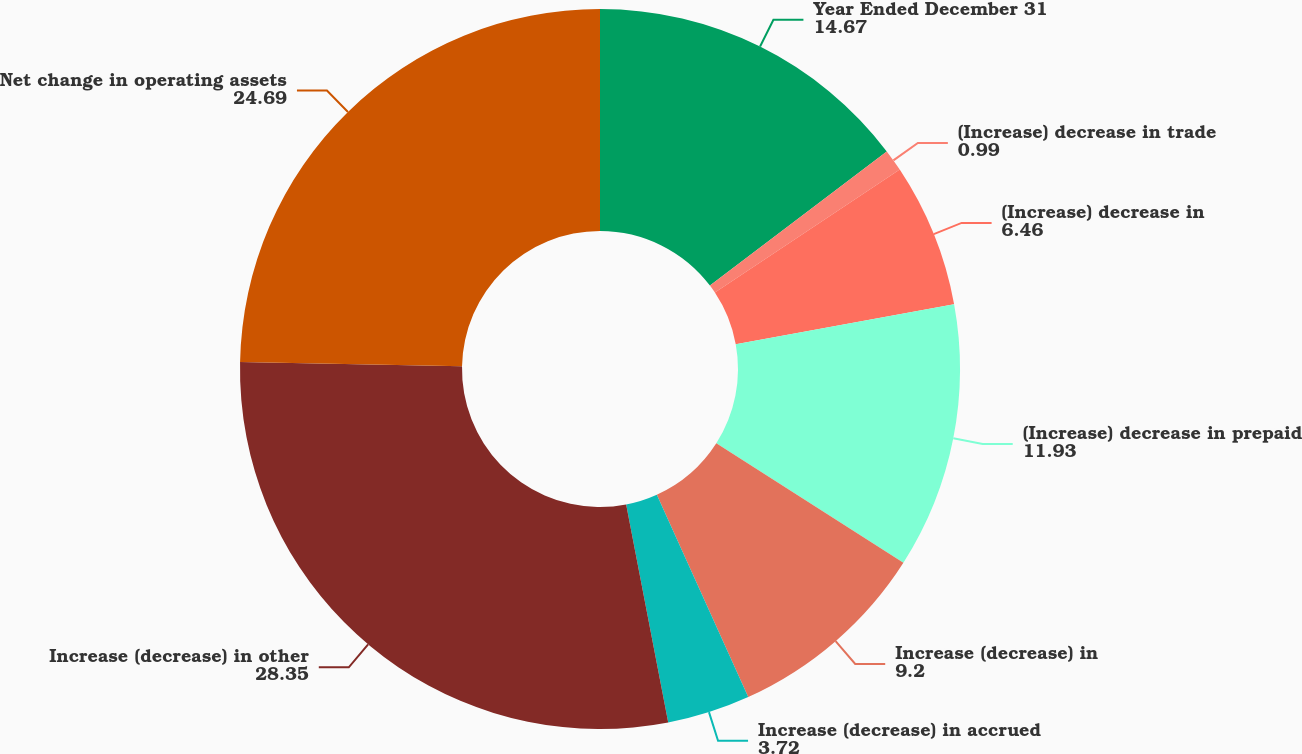Convert chart. <chart><loc_0><loc_0><loc_500><loc_500><pie_chart><fcel>Year Ended December 31<fcel>(Increase) decrease in trade<fcel>(Increase) decrease in<fcel>(Increase) decrease in prepaid<fcel>Increase (decrease) in<fcel>Increase (decrease) in accrued<fcel>Increase (decrease) in other<fcel>Net change in operating assets<nl><fcel>14.67%<fcel>0.99%<fcel>6.46%<fcel>11.93%<fcel>9.2%<fcel>3.72%<fcel>28.35%<fcel>24.69%<nl></chart> 